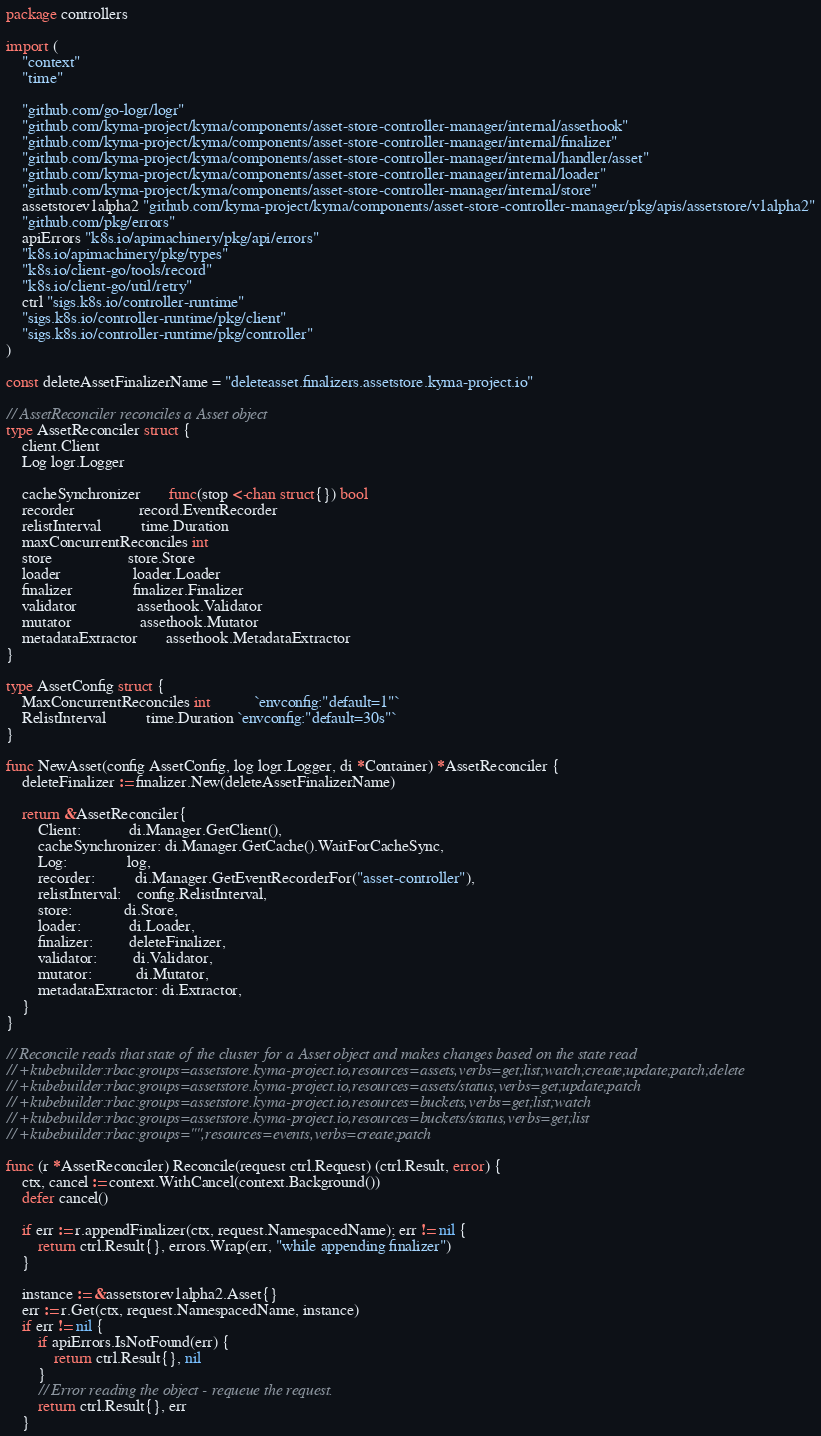Convert code to text. <code><loc_0><loc_0><loc_500><loc_500><_Go_>package controllers

import (
	"context"
	"time"

	"github.com/go-logr/logr"
	"github.com/kyma-project/kyma/components/asset-store-controller-manager/internal/assethook"
	"github.com/kyma-project/kyma/components/asset-store-controller-manager/internal/finalizer"
	"github.com/kyma-project/kyma/components/asset-store-controller-manager/internal/handler/asset"
	"github.com/kyma-project/kyma/components/asset-store-controller-manager/internal/loader"
	"github.com/kyma-project/kyma/components/asset-store-controller-manager/internal/store"
	assetstorev1alpha2 "github.com/kyma-project/kyma/components/asset-store-controller-manager/pkg/apis/assetstore/v1alpha2"
	"github.com/pkg/errors"
	apiErrors "k8s.io/apimachinery/pkg/api/errors"
	"k8s.io/apimachinery/pkg/types"
	"k8s.io/client-go/tools/record"
	"k8s.io/client-go/util/retry"
	ctrl "sigs.k8s.io/controller-runtime"
	"sigs.k8s.io/controller-runtime/pkg/client"
	"sigs.k8s.io/controller-runtime/pkg/controller"
)

const deleteAssetFinalizerName = "deleteasset.finalizers.assetstore.kyma-project.io"

// AssetReconciler reconciles a Asset object
type AssetReconciler struct {
	client.Client
	Log logr.Logger

	cacheSynchronizer       func(stop <-chan struct{}) bool
	recorder                record.EventRecorder
	relistInterval          time.Duration
	maxConcurrentReconciles int
	store                   store.Store
	loader                  loader.Loader
	finalizer               finalizer.Finalizer
	validator               assethook.Validator
	mutator                 assethook.Mutator
	metadataExtractor       assethook.MetadataExtractor
}

type AssetConfig struct {
	MaxConcurrentReconciles int           `envconfig:"default=1"`
	RelistInterval          time.Duration `envconfig:"default=30s"`
}

func NewAsset(config AssetConfig, log logr.Logger, di *Container) *AssetReconciler {
	deleteFinalizer := finalizer.New(deleteAssetFinalizerName)

	return &AssetReconciler{
		Client:            di.Manager.GetClient(),
		cacheSynchronizer: di.Manager.GetCache().WaitForCacheSync,
		Log:               log,
		recorder:          di.Manager.GetEventRecorderFor("asset-controller"),
		relistInterval:    config.RelistInterval,
		store:             di.Store,
		loader:            di.Loader,
		finalizer:         deleteFinalizer,
		validator:         di.Validator,
		mutator:           di.Mutator,
		metadataExtractor: di.Extractor,
	}
}

// Reconcile reads that state of the cluster for a Asset object and makes changes based on the state read
// +kubebuilder:rbac:groups=assetstore.kyma-project.io,resources=assets,verbs=get;list;watch;create;update;patch;delete
// +kubebuilder:rbac:groups=assetstore.kyma-project.io,resources=assets/status,verbs=get;update;patch
// +kubebuilder:rbac:groups=assetstore.kyma-project.io,resources=buckets,verbs=get;list;watch
// +kubebuilder:rbac:groups=assetstore.kyma-project.io,resources=buckets/status,verbs=get;list
// +kubebuilder:rbac:groups="",resources=events,verbs=create;patch

func (r *AssetReconciler) Reconcile(request ctrl.Request) (ctrl.Result, error) {
	ctx, cancel := context.WithCancel(context.Background())
	defer cancel()

	if err := r.appendFinalizer(ctx, request.NamespacedName); err != nil {
		return ctrl.Result{}, errors.Wrap(err, "while appending finalizer")
	}

	instance := &assetstorev1alpha2.Asset{}
	err := r.Get(ctx, request.NamespacedName, instance)
	if err != nil {
		if apiErrors.IsNotFound(err) {
			return ctrl.Result{}, nil
		}
		// Error reading the object - requeue the request.
		return ctrl.Result{}, err
	}
</code> 